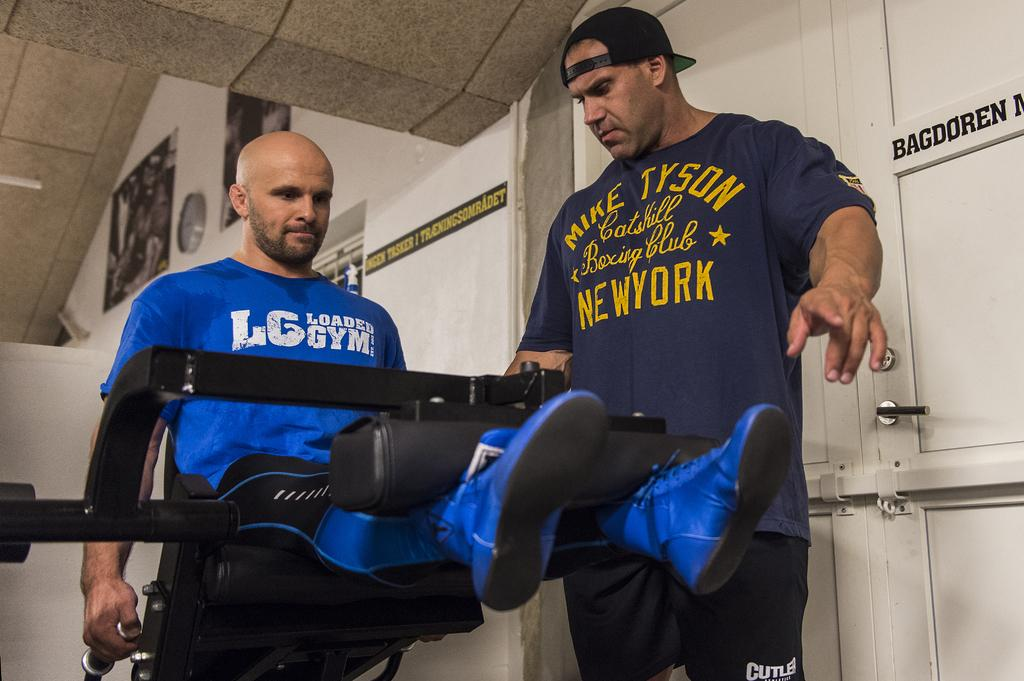<image>
Offer a succinct explanation of the picture presented. a shirt that has the state of New York on it 